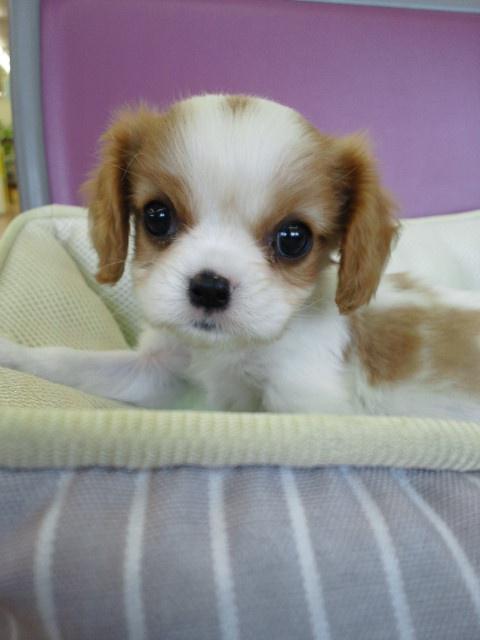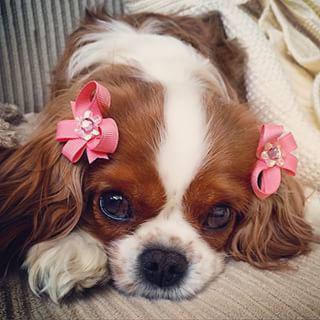The first image is the image on the left, the second image is the image on the right. Considering the images on both sides, is "One image shows a spaniel puppy inside a soft-sided pet bed, with its head upright instead of draped over the edge." valid? Answer yes or no. Yes. The first image is the image on the left, the second image is the image on the right. For the images displayed, is the sentence "The dog in the image on the right is lying down." factually correct? Answer yes or no. Yes. 